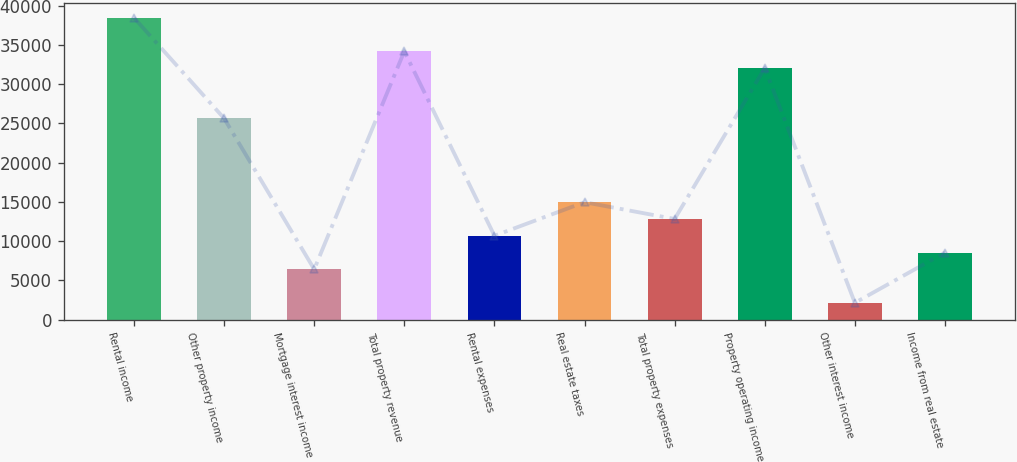Convert chart. <chart><loc_0><loc_0><loc_500><loc_500><bar_chart><fcel>Rental income<fcel>Other property income<fcel>Mortgage interest income<fcel>Total property revenue<fcel>Rental expenses<fcel>Real estate taxes<fcel>Total property expenses<fcel>Property operating income<fcel>Other interest income<fcel>Income from real estate<nl><fcel>38459.8<fcel>25646.2<fcel>6425.8<fcel>34188.6<fcel>10697<fcel>14968.2<fcel>12832.6<fcel>32053<fcel>2154.6<fcel>8561.4<nl></chart> 